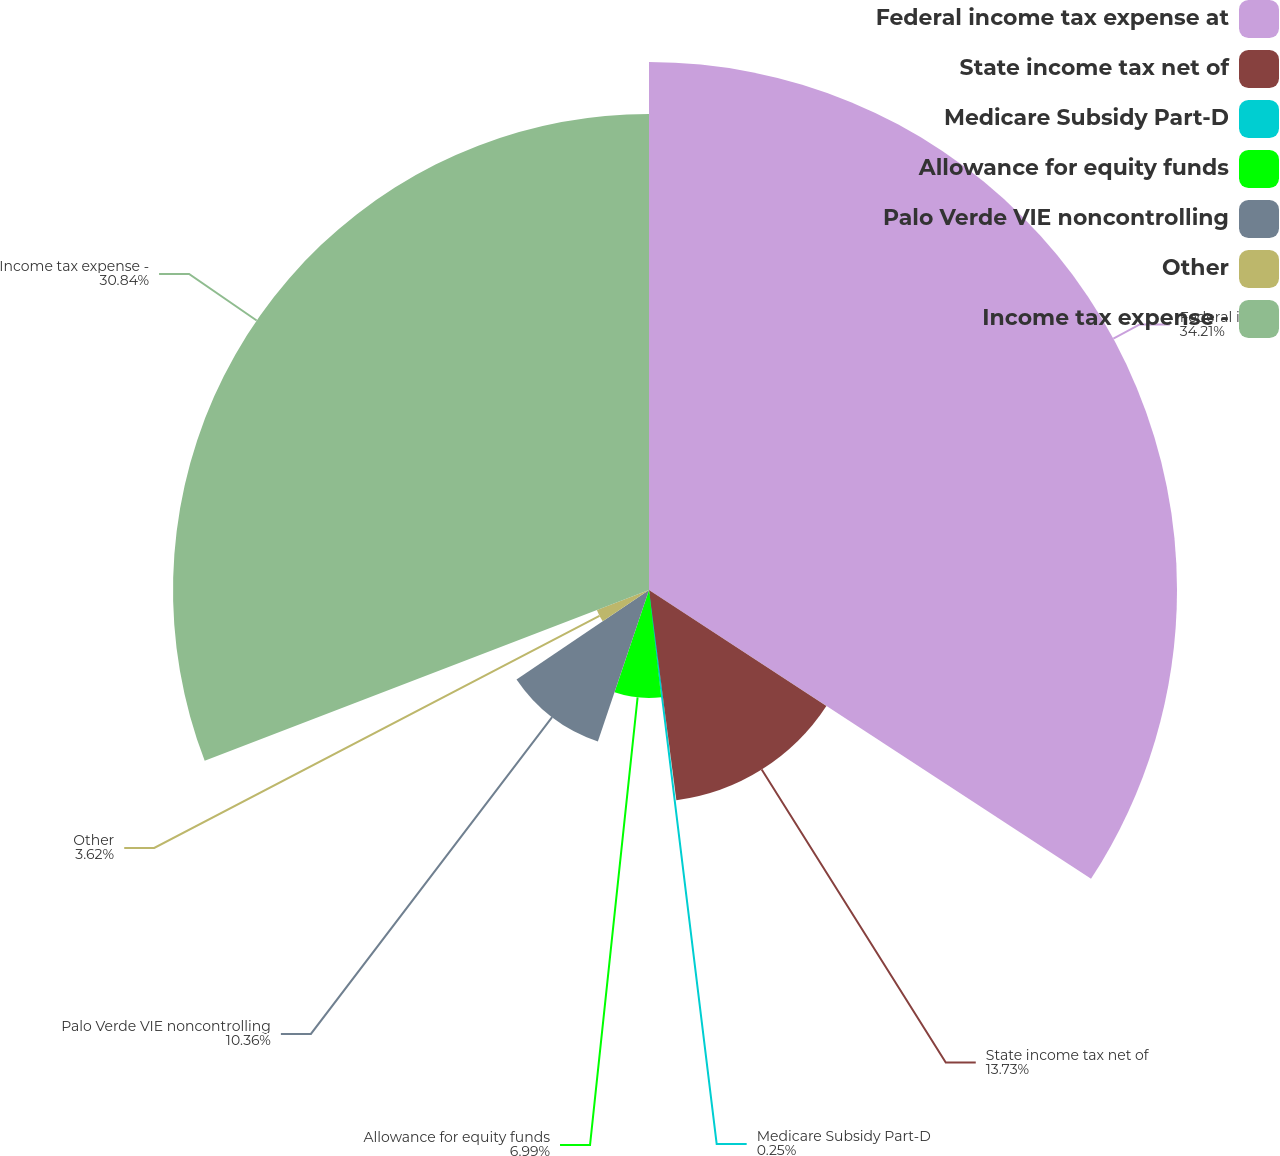<chart> <loc_0><loc_0><loc_500><loc_500><pie_chart><fcel>Federal income tax expense at<fcel>State income tax net of<fcel>Medicare Subsidy Part-D<fcel>Allowance for equity funds<fcel>Palo Verde VIE noncontrolling<fcel>Other<fcel>Income tax expense -<nl><fcel>34.21%<fcel>13.73%<fcel>0.25%<fcel>6.99%<fcel>10.36%<fcel>3.62%<fcel>30.84%<nl></chart> 